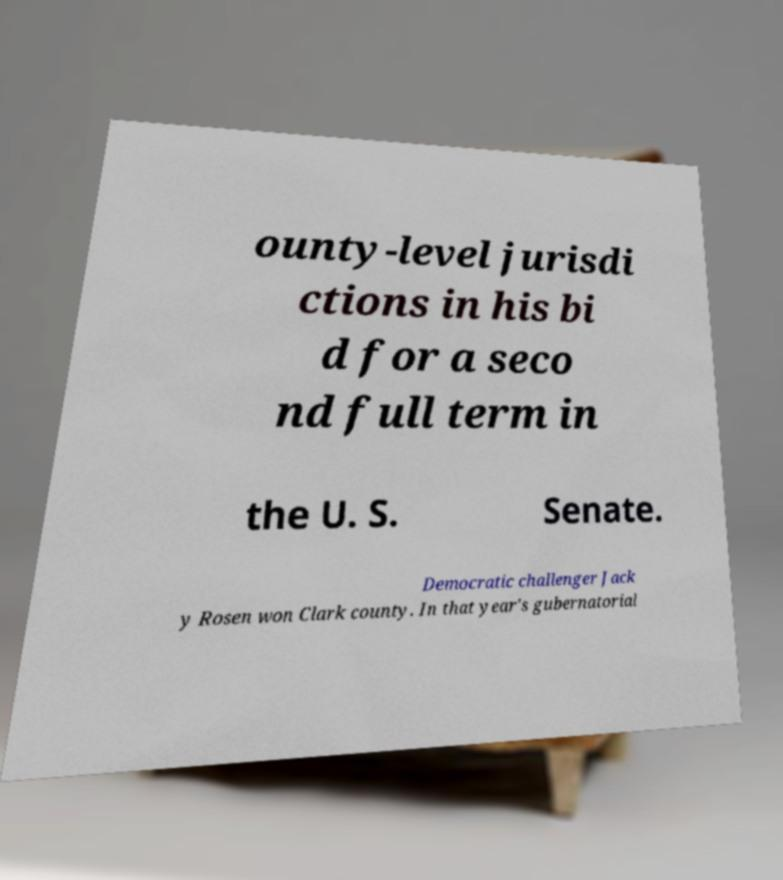Please read and relay the text visible in this image. What does it say? ounty-level jurisdi ctions in his bi d for a seco nd full term in the U. S. Senate. Democratic challenger Jack y Rosen won Clark county. In that year's gubernatorial 